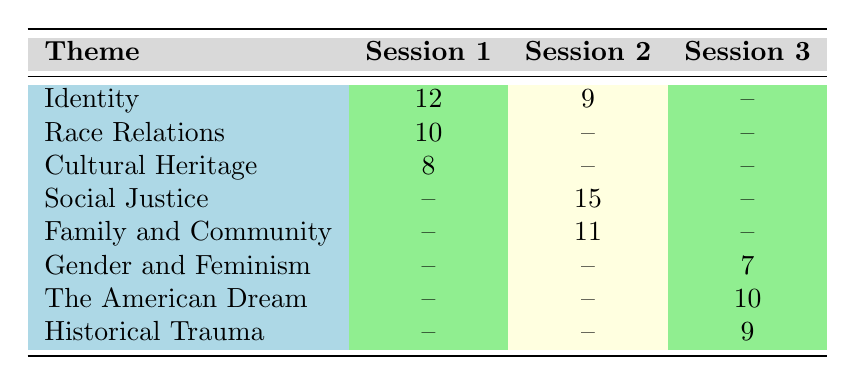What is the discussion count for the theme "Identity" in Session 1? The table shows that for the theme "Identity" in Session 1, the discussion count is listed directly as 12.
Answer: 12 Which theme has the highest discussion count in Session 2? In Session 2, the themes and their discussion counts are Social Justice (15), Identity (9), and Family and Community (11). Comparing these values, Social Justice has the highest count at 15.
Answer: Social Justice How many themes were discussed in Session 3? Looking at Session 3, the themes listed are Gender and Feminism, The American Dream, and Historical Trauma. There are a total of 3 themes mentioned for this session.
Answer: 3 What is the total discussion count for themes in Session 1? The discussion counts for Session 1 are 12 (Identity), 10 (Race Relations), and 8 (Cultural Heritage). Summing these values gives 12 + 10 + 8 = 30.
Answer: 30 Is there a theme discussed in all three sessions? Reviewing the table, each theme presented is unique to its respective session. Therefore, there is no theme that appears in all three sessions.
Answer: No What is the difference in discussion counts for the theme "Race Relations" between Session 1 and Session 2? The discussion count for "Race Relations" in Session 1 is 10, while in Session 2, it is not present (denoted by --). Thus, the difference calculation shows a count of 10 - 0 = 10.
Answer: 10 Which author is associated with the theme "Social Justice"? The table indicates that the theme "Social Justice" for Session 2 is associated with the book "Beloved" by the author Toni Morrison.
Answer: Toni Morrison What is the average discussion count for themes across all sessions? Adding up all discussion counts: 12 + 10 + 8 + 15 + 9 + 11 + 7 + 10 + 9 = 81, and there are 9 themes in total. Thus, the average is 81/9 = 9.
Answer: 9 How many discussion counts are recorded for the theme "Gender and Feminism"? The table states that the discussion count for the theme "Gender and Feminism" in Session 3 is 7, and it does not appear in other sessions. Therefore, there is only one recorded count.
Answer: 7 